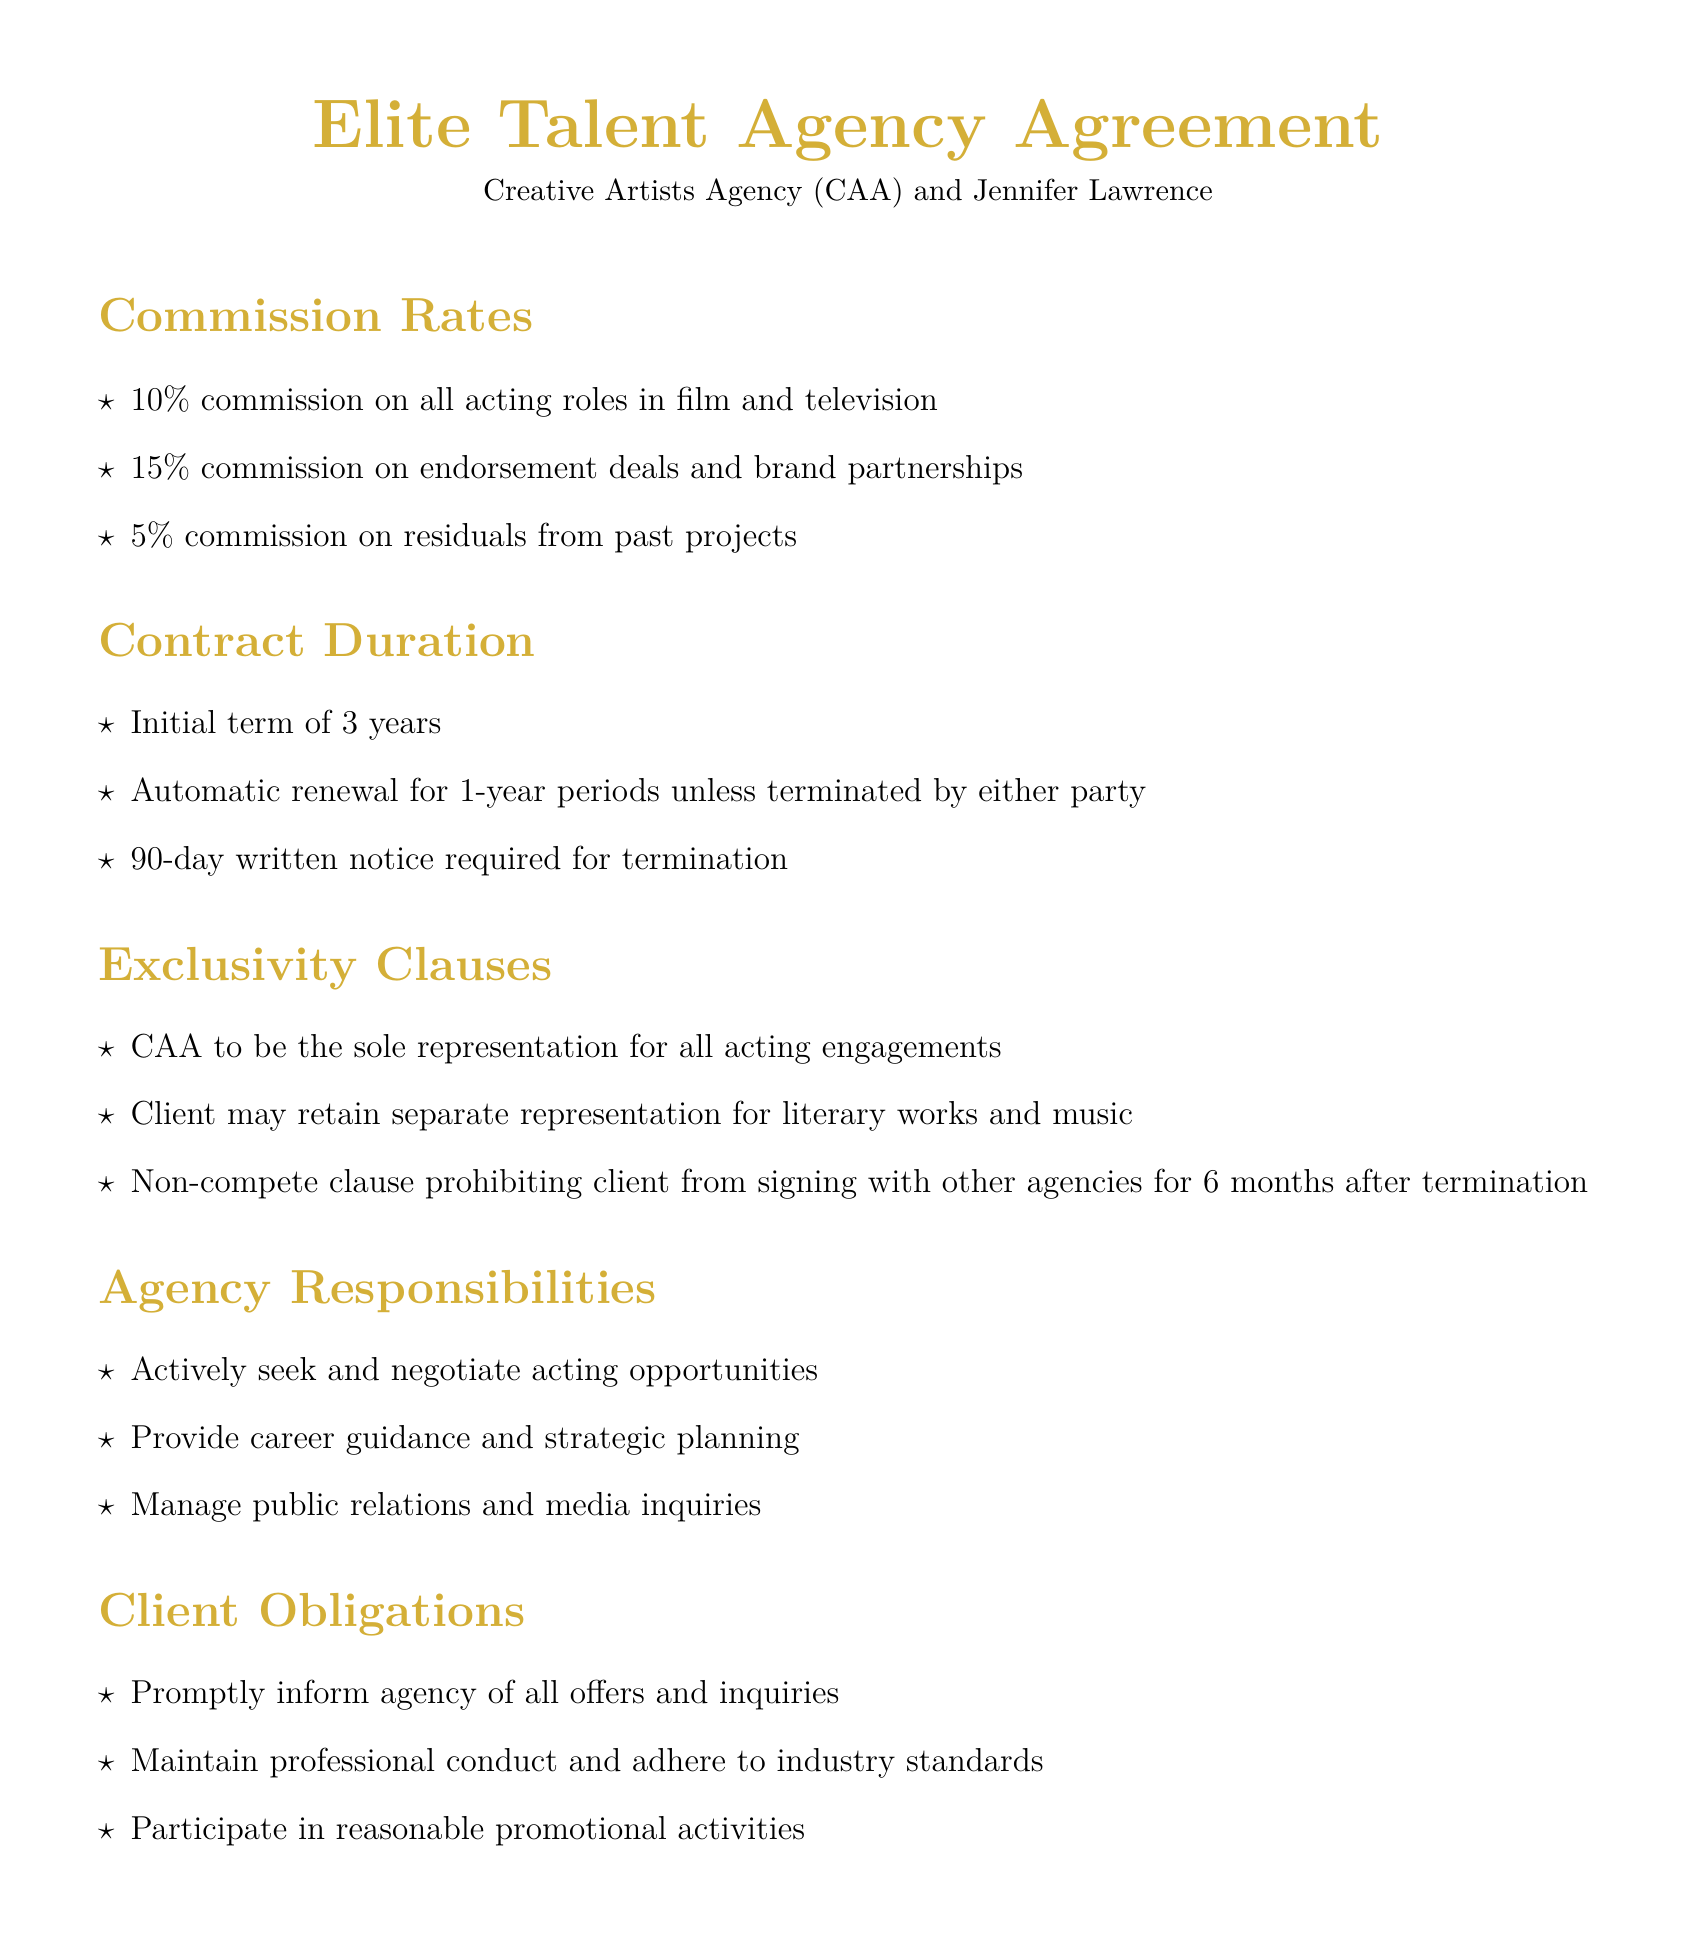What is the commission rate for endorsement deals? The commission rate for endorsement deals is specifically outlined in the "Commission Rates" section of the document.
Answer: 15% What is the initial term duration of the contract? The initial term duration is mentioned in the "Contract Duration" section.
Answer: 3 years Who is the agency representative? The agency representative's name is listed at the end of the document under "Agency Representative."
Answer: Bryan Lourd What is the non-compete duration after termination? The non-compete duration is specified in the "Exclusivity Clauses" section of the document.
Answer: 6 months Where is arbitration located? The location for arbitration is stated in the "Dispute Resolution" section of the document.
Answer: Los Angeles, California What are the client obligations regarding offers? The obligations regarding offers are specified in the "Client Obligations" section.
Answer: Promptly inform agency How long must notice be given for termination? The notice period for termination is detailed under "Contract Duration."
Answer: 90 days What is the governing law for this agreement? The governing law is specified in the "Dispute Resolution" section.
Answer: California State Law Who conducted the review of the agreement? The review of the agreement is mentioned at the end of the document.
Answer: Ziffren Brittenham LLP 